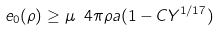Convert formula to latex. <formula><loc_0><loc_0><loc_500><loc_500>e _ { 0 } ( \rho ) \geq \mu \ 4 \pi \rho a ( 1 - C Y ^ { 1 / 1 7 } )</formula> 